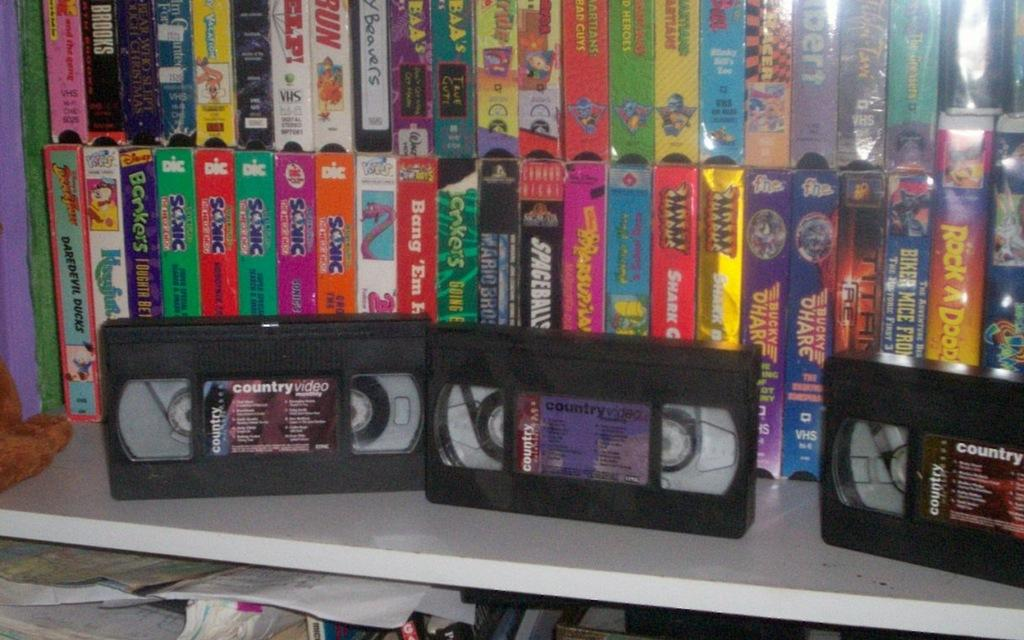<image>
Share a concise interpretation of the image provided. A bunch of all videos sitting on a white shelf. 